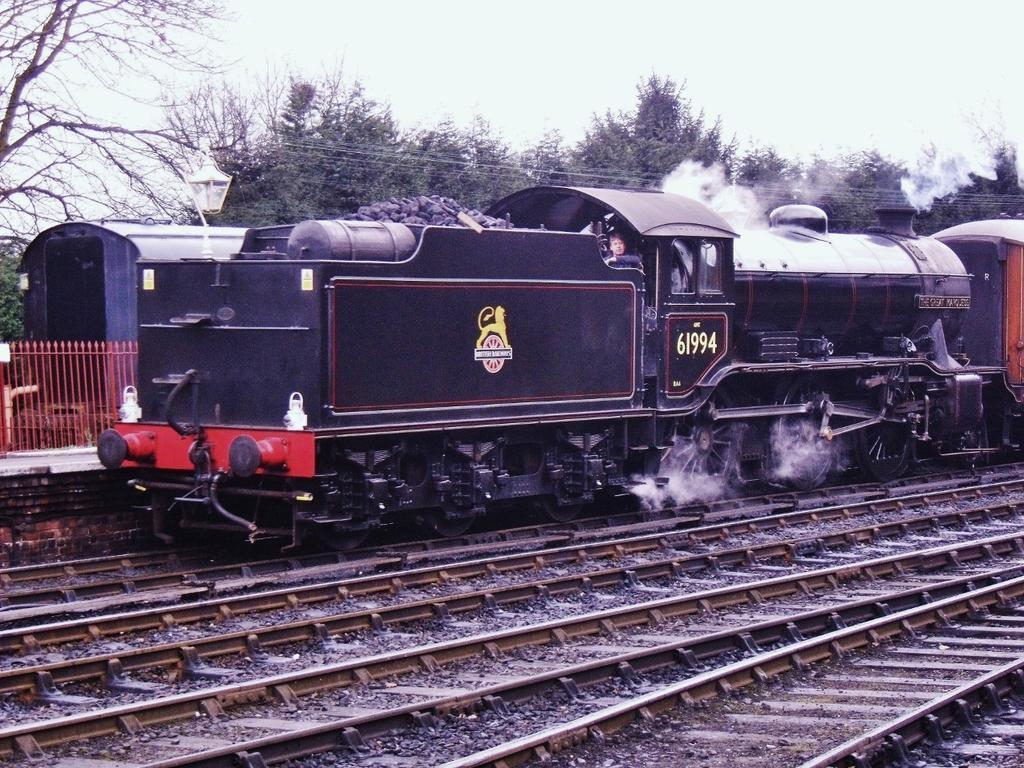How would you summarize this image in a sentence or two? In this picture, we see the train in black and red color is moving on the tracks. At the bottom, we see the railway tracks and concrete stones. On the left side, we see the railing and the platform. Behind that, we see another train. There are trees in the background. At the top, we see the sky. 